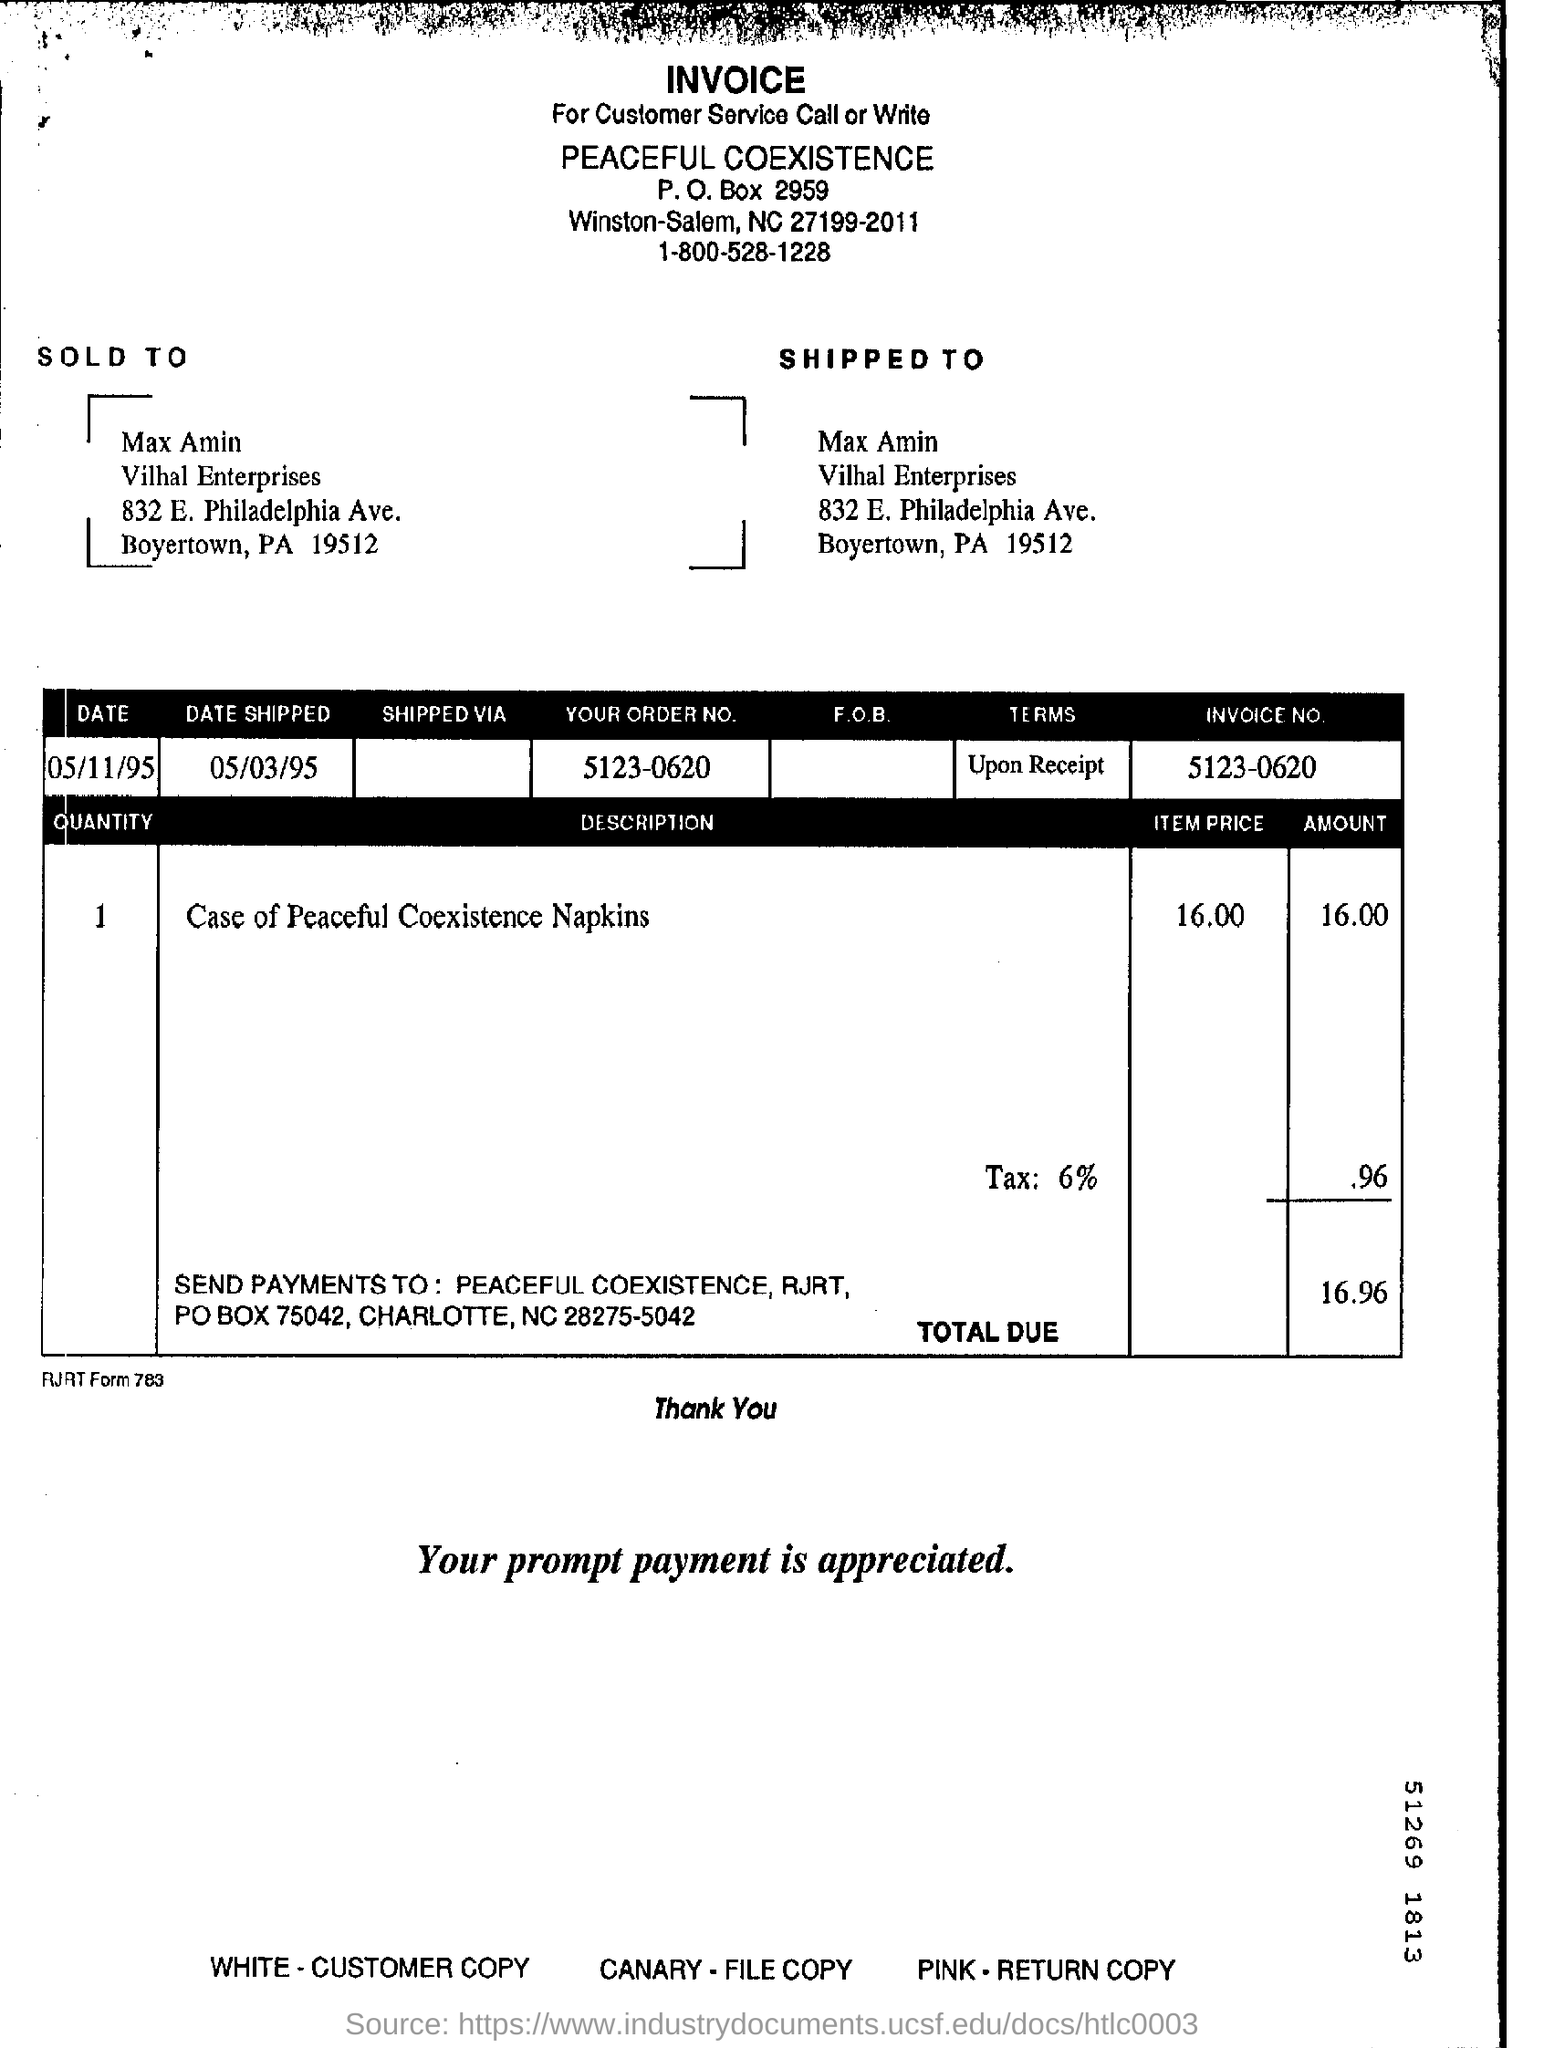Identify some key points in this picture. The item price for a case of peaceful coexistence napkins is $16.00. The date shipped is May 3, 1995. The invoice number is 5123-0620. The total due is 16.96 and (whatever comes after the decimal point) (if any). 